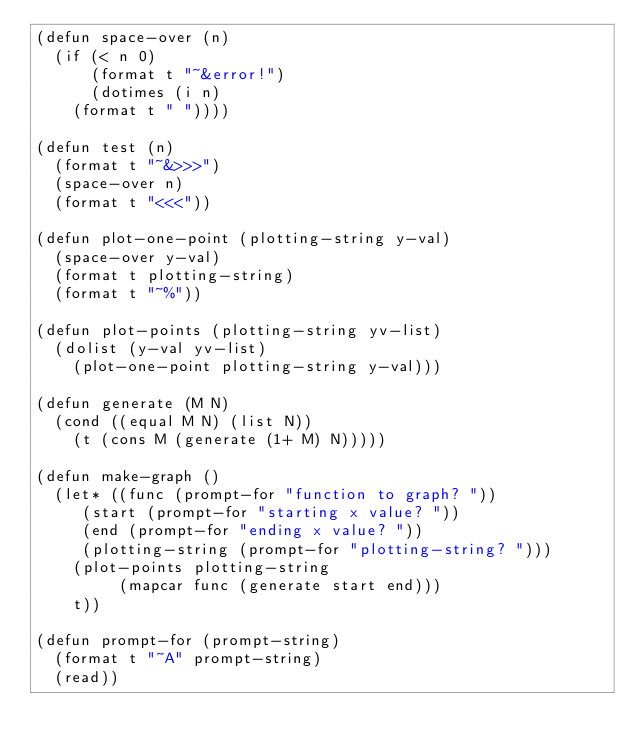Convert code to text. <code><loc_0><loc_0><loc_500><loc_500><_Lisp_>(defun space-over (n)
  (if (< n 0)
      (format t "~&error!")
      (dotimes (i n)
	(format t " "))))

(defun test (n)
  (format t "~&>>>")
  (space-over n)
  (format t "<<<"))

(defun plot-one-point (plotting-string y-val)
  (space-over y-val)
  (format t plotting-string)
  (format t "~%"))

(defun plot-points (plotting-string yv-list)
  (dolist (y-val yv-list)
    (plot-one-point plotting-string y-val)))

(defun generate (M N)
  (cond ((equal M N) (list N))
	(t (cons M (generate (1+ M) N)))))

(defun make-graph ()
  (let* ((func (prompt-for "function to graph? "))
	 (start (prompt-for "starting x value? "))
	 (end (prompt-for "ending x value? "))
	 (plotting-string (prompt-for "plotting-string? ")))
    (plot-points plotting-string
		 (mapcar func (generate start end)))
    t))

(defun prompt-for (prompt-string)
  (format t "~A" prompt-string)
  (read))
  
</code> 